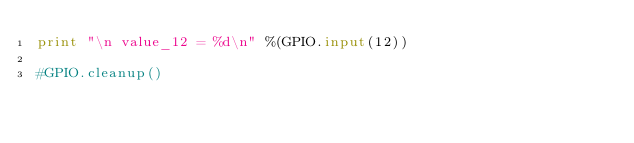<code> <loc_0><loc_0><loc_500><loc_500><_Python_>print "\n value_12 = %d\n" %(GPIO.input(12))	

#GPIO.cleanup()
</code> 